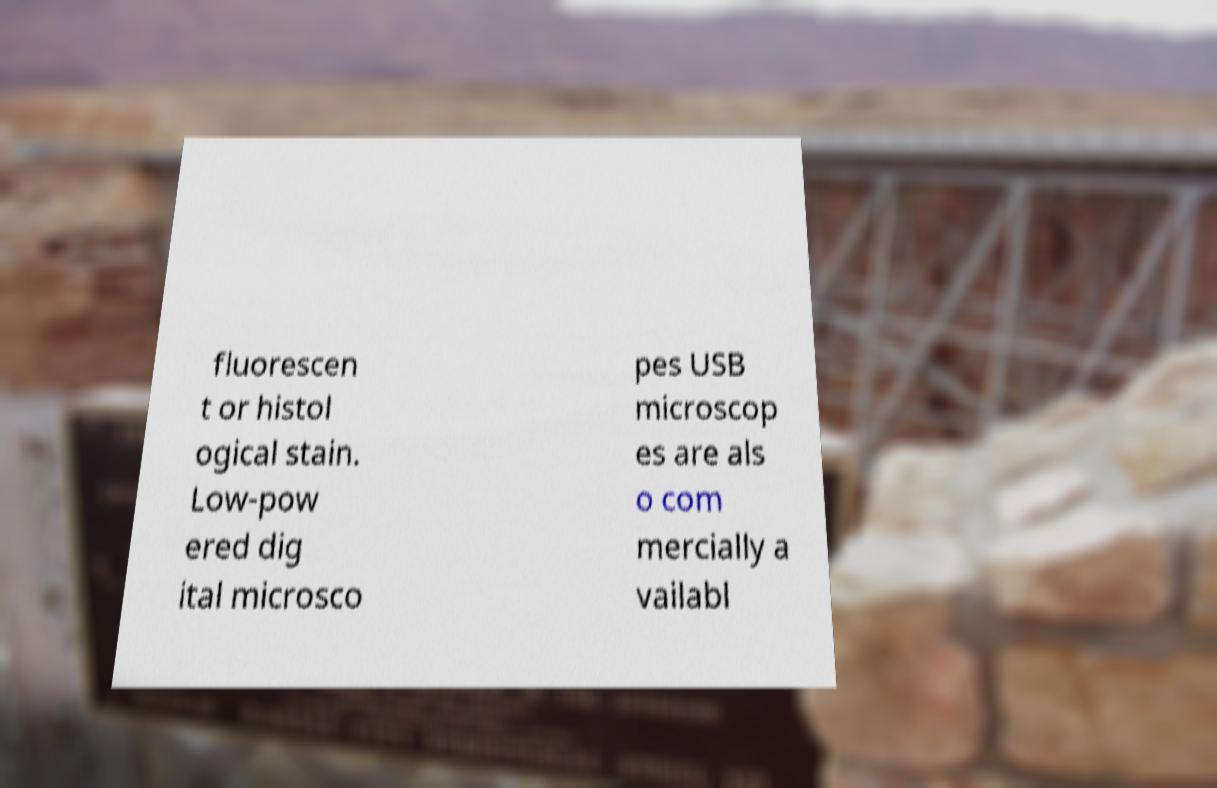For documentation purposes, I need the text within this image transcribed. Could you provide that? fluorescen t or histol ogical stain. Low-pow ered dig ital microsco pes USB microscop es are als o com mercially a vailabl 